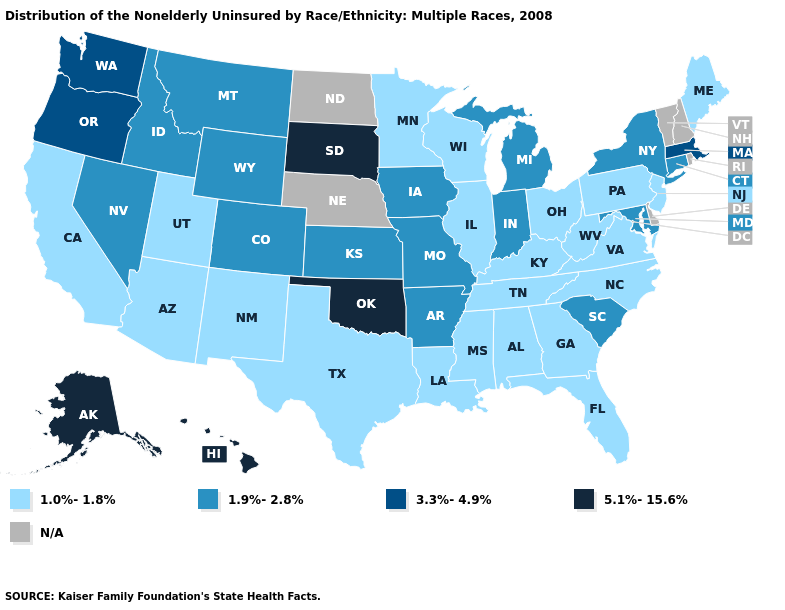Name the states that have a value in the range N/A?
Be succinct. Delaware, Nebraska, New Hampshire, North Dakota, Rhode Island, Vermont. What is the highest value in the USA?
Short answer required. 5.1%-15.6%. What is the value of Utah?
Quick response, please. 1.0%-1.8%. What is the value of Kansas?
Be succinct. 1.9%-2.8%. What is the value of New Hampshire?
Keep it brief. N/A. What is the highest value in the USA?
Short answer required. 5.1%-15.6%. Name the states that have a value in the range 3.3%-4.9%?
Keep it brief. Massachusetts, Oregon, Washington. What is the value of Iowa?
Be succinct. 1.9%-2.8%. Name the states that have a value in the range 5.1%-15.6%?
Short answer required. Alaska, Hawaii, Oklahoma, South Dakota. Name the states that have a value in the range 3.3%-4.9%?
Be succinct. Massachusetts, Oregon, Washington. What is the value of Ohio?
Concise answer only. 1.0%-1.8%. What is the highest value in states that border Ohio?
Answer briefly. 1.9%-2.8%. Does Oklahoma have the highest value in the South?
Be succinct. Yes. What is the lowest value in states that border Pennsylvania?
Short answer required. 1.0%-1.8%. Among the states that border Kansas , does Oklahoma have the lowest value?
Concise answer only. No. 